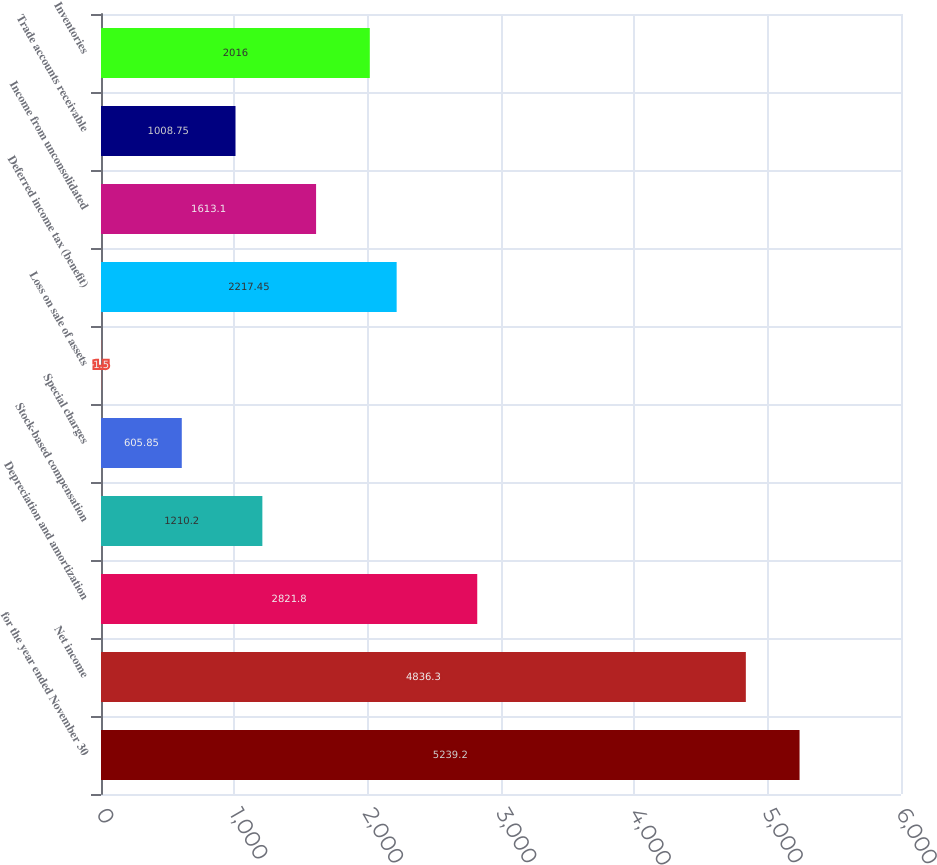Convert chart to OTSL. <chart><loc_0><loc_0><loc_500><loc_500><bar_chart><fcel>for the year ended November 30<fcel>Net income<fcel>Depreciation and amortization<fcel>Stock-based compensation<fcel>Special charges<fcel>Loss on sale of assets<fcel>Deferred income tax (benefit)<fcel>Income from unconsolidated<fcel>Trade accounts receivable<fcel>Inventories<nl><fcel>5239.2<fcel>4836.3<fcel>2821.8<fcel>1210.2<fcel>605.85<fcel>1.5<fcel>2217.45<fcel>1613.1<fcel>1008.75<fcel>2016<nl></chart> 